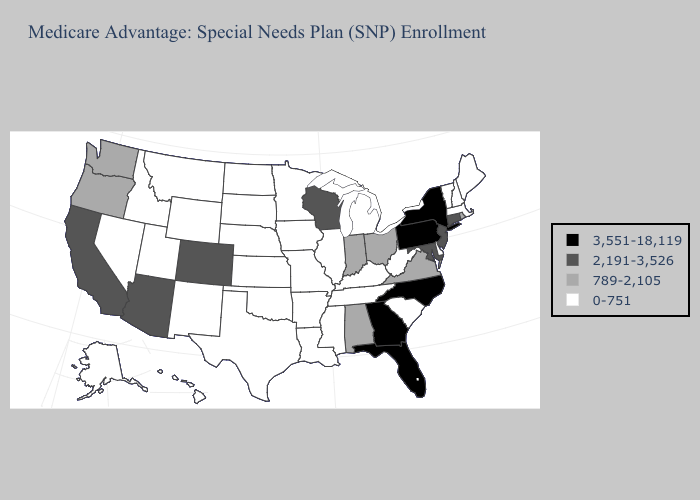Name the states that have a value in the range 0-751?
Answer briefly. Alaska, Arkansas, Delaware, Hawaii, Idaho, Illinois, Iowa, Kansas, Kentucky, Louisiana, Maine, Massachusetts, Michigan, Minnesota, Mississippi, Missouri, Montana, Nebraska, Nevada, New Hampshire, New Mexico, North Dakota, Oklahoma, South Carolina, South Dakota, Tennessee, Texas, Utah, Vermont, West Virginia, Wyoming. What is the lowest value in the Northeast?
Be succinct. 0-751. Does the first symbol in the legend represent the smallest category?
Answer briefly. No. Does Mississippi have the lowest value in the South?
Concise answer only. Yes. Does Wyoming have a lower value than South Carolina?
Concise answer only. No. Does Kansas have a higher value than South Carolina?
Keep it brief. No. Among the states that border Kentucky , does Ohio have the highest value?
Write a very short answer. Yes. What is the highest value in the Northeast ?
Be succinct. 3,551-18,119. Name the states that have a value in the range 789-2,105?
Write a very short answer. Alabama, Indiana, Ohio, Oregon, Rhode Island, Virginia, Washington. Which states have the lowest value in the USA?
Answer briefly. Alaska, Arkansas, Delaware, Hawaii, Idaho, Illinois, Iowa, Kansas, Kentucky, Louisiana, Maine, Massachusetts, Michigan, Minnesota, Mississippi, Missouri, Montana, Nebraska, Nevada, New Hampshire, New Mexico, North Dakota, Oklahoma, South Carolina, South Dakota, Tennessee, Texas, Utah, Vermont, West Virginia, Wyoming. Does Washington have the lowest value in the USA?
Write a very short answer. No. Among the states that border Missouri , which have the lowest value?
Be succinct. Arkansas, Illinois, Iowa, Kansas, Kentucky, Nebraska, Oklahoma, Tennessee. Does Washington have the highest value in the USA?
Write a very short answer. No. Name the states that have a value in the range 3,551-18,119?
Answer briefly. Florida, Georgia, New York, North Carolina, Pennsylvania. 